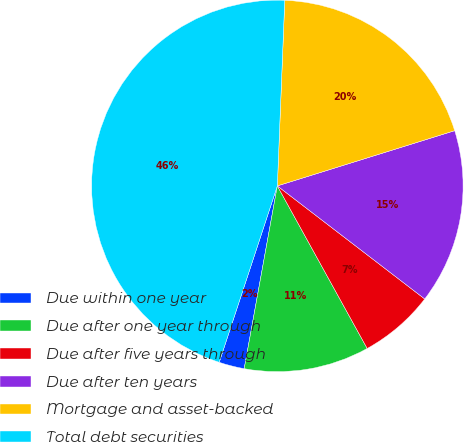Convert chart. <chart><loc_0><loc_0><loc_500><loc_500><pie_chart><fcel>Due within one year<fcel>Due after one year through<fcel>Due after five years through<fcel>Due after ten years<fcel>Mortgage and asset-backed<fcel>Total debt securities<nl><fcel>2.21%<fcel>10.89%<fcel>6.55%<fcel>15.22%<fcel>19.56%<fcel>45.57%<nl></chart> 